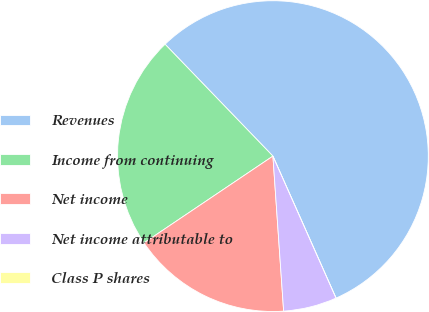Convert chart. <chart><loc_0><loc_0><loc_500><loc_500><pie_chart><fcel>Revenues<fcel>Income from continuing<fcel>Net income<fcel>Net income attributable to<fcel>Class P shares<nl><fcel>55.55%<fcel>22.22%<fcel>16.67%<fcel>5.56%<fcel>0.0%<nl></chart> 